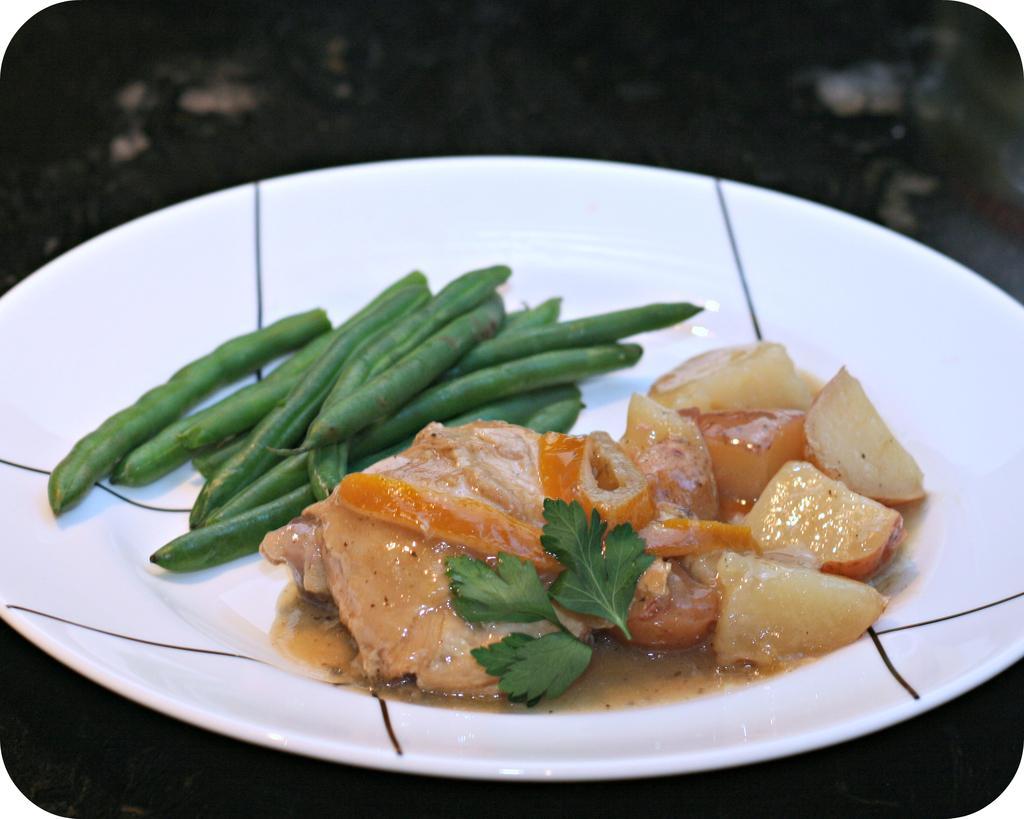How would you summarize this image in a sentence or two? In this image there is a plate having few beans and some food and leaves on it. 